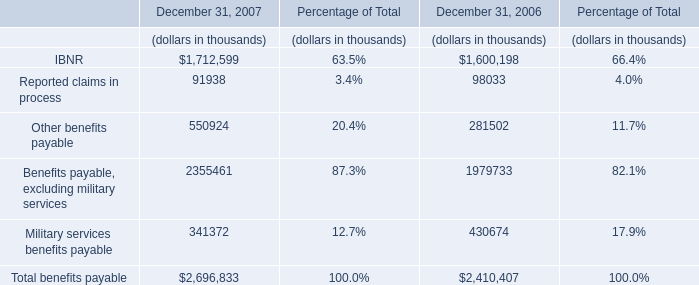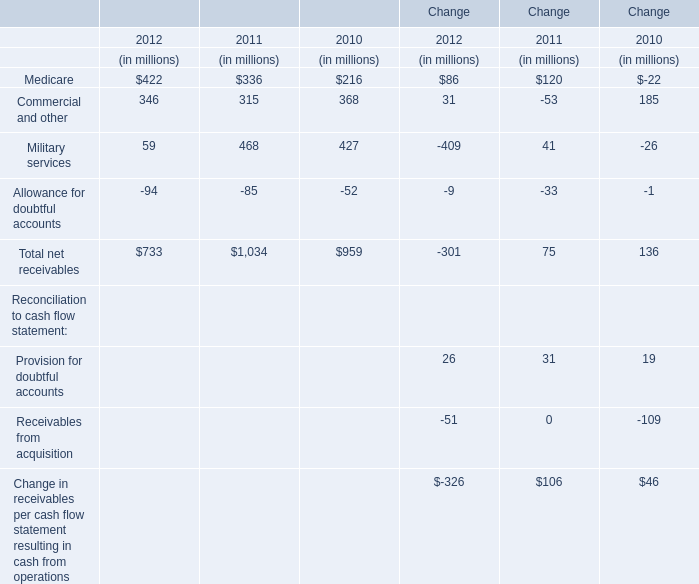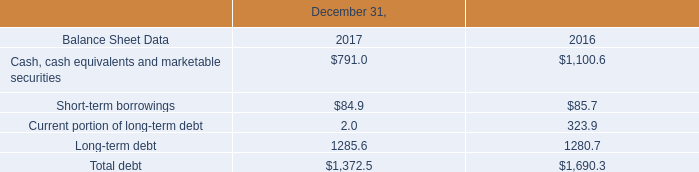in 2018 , how many approximate shares would have been held for the entire year to pay the approximate $ 320 in dividends over the 12 months? 
Computations: (320 / (0.21 * 4))
Answer: 380.95238. 